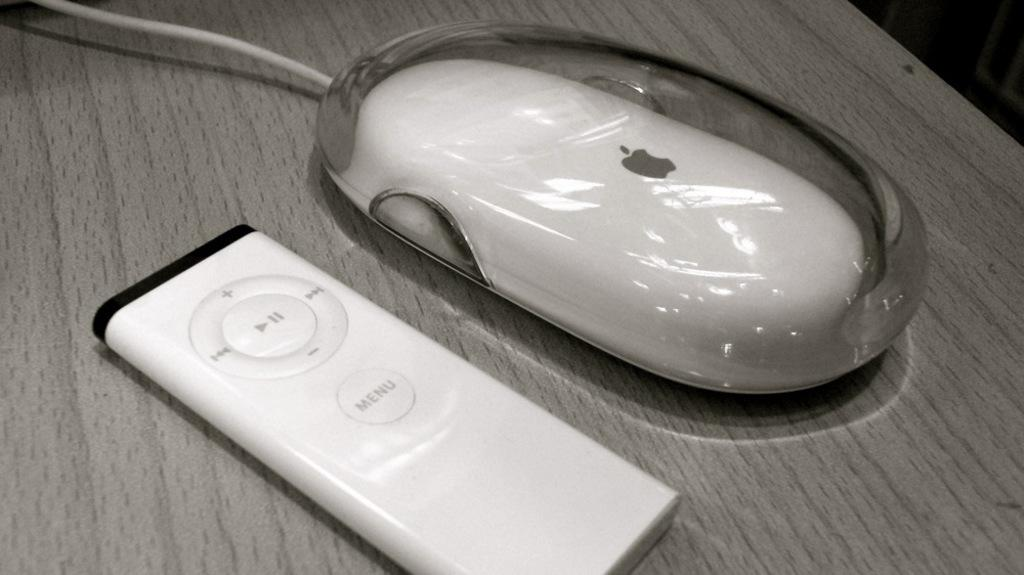What type of animal is present in the image? There is a mouse in the image. What object can be seen on the table in the image? There is a remote on the table in the image. What color is the table in the image? The table is gray in color. Can you see the mouse's friend wearing a crown in the image? There is no friend or crown present in the image; it only features a mouse and a remote on a gray table. 